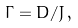Convert formula to latex. <formula><loc_0><loc_0><loc_500><loc_500>\Gamma = D / J \, ,</formula> 